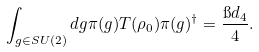Convert formula to latex. <formula><loc_0><loc_0><loc_500><loc_500>\int _ { g \in S U ( 2 ) } d g \pi ( g ) T ( \rho _ { 0 } ) \pi ( g ) ^ { \dagger } = \frac { \i d _ { 4 } } { 4 } .</formula> 